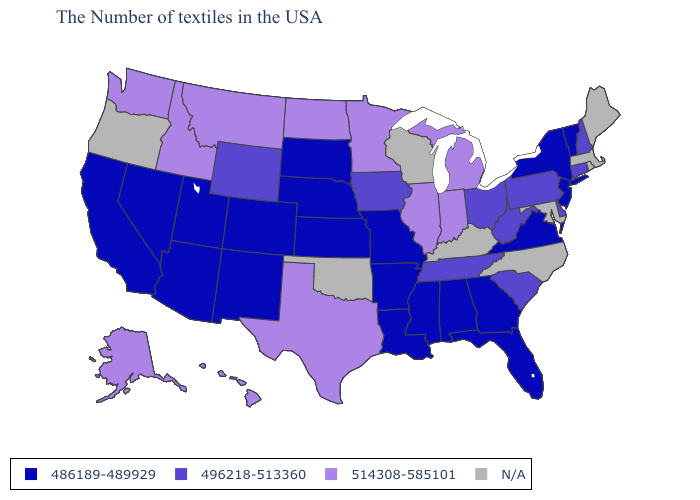Among the states that border Wyoming , which have the highest value?
Keep it brief. Montana, Idaho. What is the value of South Carolina?
Be succinct. 496218-513360. Does the first symbol in the legend represent the smallest category?
Give a very brief answer. Yes. Does Alaska have the highest value in the USA?
Be succinct. Yes. What is the value of Connecticut?
Concise answer only. 496218-513360. What is the value of Florida?
Keep it brief. 486189-489929. Does Tennessee have the lowest value in the USA?
Give a very brief answer. No. What is the value of Utah?
Be succinct. 486189-489929. What is the lowest value in the MidWest?
Give a very brief answer. 486189-489929. Which states have the lowest value in the MidWest?
Concise answer only. Missouri, Kansas, Nebraska, South Dakota. What is the highest value in the MidWest ?
Quick response, please. 514308-585101. What is the value of New York?
Answer briefly. 486189-489929. Name the states that have a value in the range 514308-585101?
Be succinct. Michigan, Indiana, Illinois, Minnesota, Texas, North Dakota, Montana, Idaho, Washington, Alaska, Hawaii. 